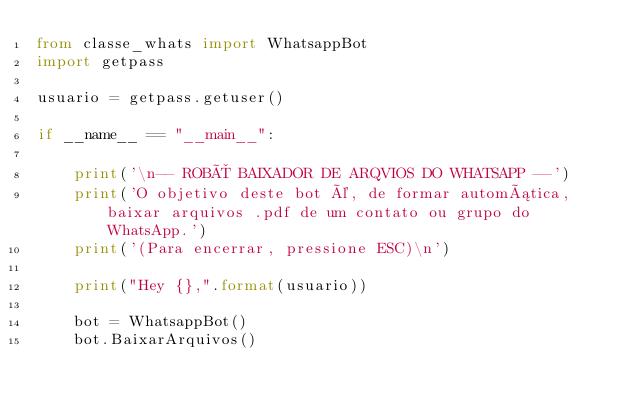Convert code to text. <code><loc_0><loc_0><loc_500><loc_500><_Python_>from classe_whats import WhatsappBot
import getpass

usuario = getpass.getuser()

if __name__ == "__main__":

    print('\n-- ROBÔ BAIXADOR DE ARQVIOS DO WHATSAPP --')
    print('O objetivo deste bot é, de formar automática, baixar arquivos .pdf de um contato ou grupo do WhatsApp.')
    print('(Para encerrar, pressione ESC)\n')

    print("Hey {},".format(usuario))

    bot = WhatsappBot()
    bot.BaixarArquivos()</code> 